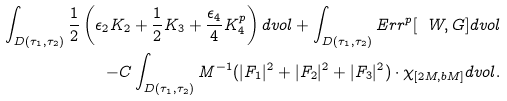Convert formula to latex. <formula><loc_0><loc_0><loc_500><loc_500>\int _ { D ( \tau _ { 1 } , \tau _ { 2 } ) } \frac { 1 } { 2 } \left ( \epsilon _ { 2 } K _ { 2 } + \frac { 1 } { 2 } K _ { 3 } + \frac { \epsilon _ { 4 } } { 4 } K ^ { p } _ { 4 } \right ) d v o l + \int _ { D ( \tau _ { 1 } , \tau _ { 2 } ) } E r r ^ { p } [ \ W , G ] d v o l \\ - C \int _ { D ( \tau _ { 1 } , \tau _ { 2 } ) } M ^ { - 1 } ( | F _ { 1 } | ^ { 2 } + | F _ { 2 } | ^ { 2 } + | F _ { 3 } | ^ { 2 } ) \cdot \chi _ { [ 2 M , b M ] } d v o l .</formula> 